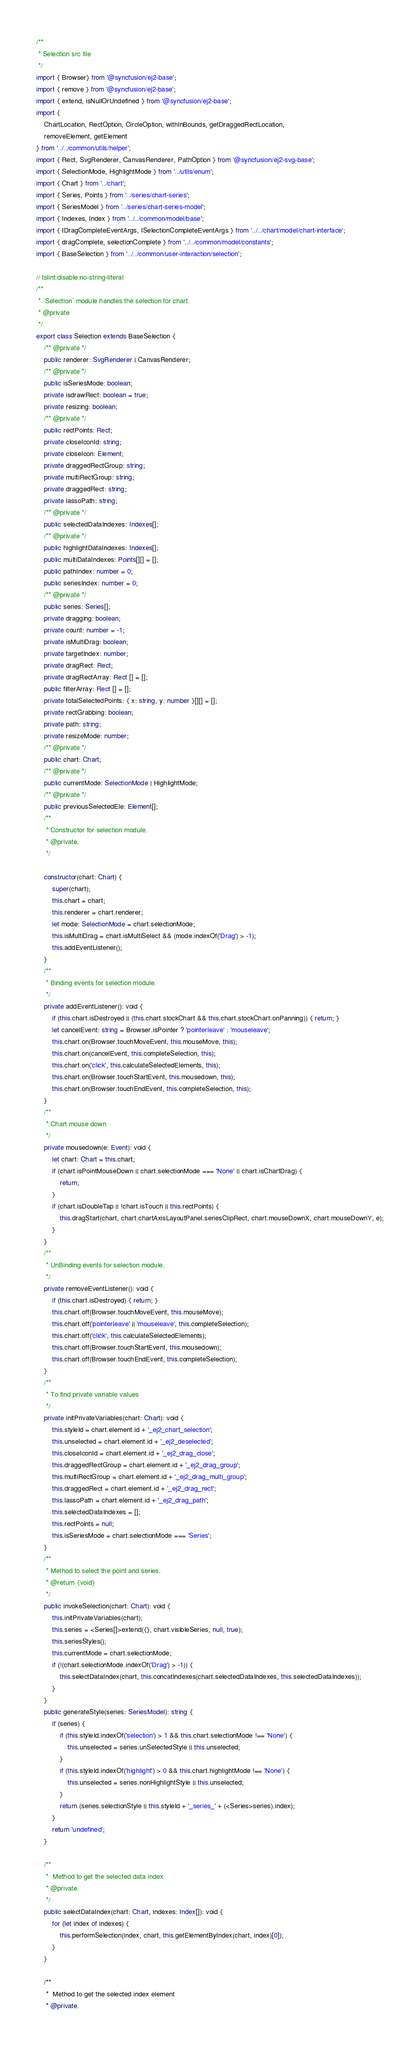Convert code to text. <code><loc_0><loc_0><loc_500><loc_500><_TypeScript_>/**
 * Selection src file
 */
import { Browser} from '@syncfusion/ej2-base';
import { remove } from '@syncfusion/ej2-base';
import { extend, isNullOrUndefined } from '@syncfusion/ej2-base';
import {
    ChartLocation, RectOption, CircleOption, withInBounds, getDraggedRectLocation,
    removeElement, getElement
} from '../../common/utils/helper';
import { Rect, SvgRenderer, CanvasRenderer, PathOption } from '@syncfusion/ej2-svg-base';
import { SelectionMode, HighlightMode } from '../utils/enum';
import { Chart } from '../chart';
import { Series, Points } from '../series/chart-series';
import { SeriesModel } from '../series/chart-series-model';
import { Indexes, Index } from '../../common/model/base';
import { IDragCompleteEventArgs, ISelectionCompleteEventArgs } from '../../chart/model/chart-interface';
import { dragComplete, selectionComplete } from '../../common/model/constants';
import { BaseSelection } from '../../common/user-interaction/selection';

// tslint:disable:no-string-literal
/**
 * `Selection` module handles the selection for chart.
 * @private
 */
export class Selection extends BaseSelection {
    /** @private */
    public renderer: SvgRenderer | CanvasRenderer;
    /** @private */
    public isSeriesMode: boolean;
    private isdrawRect: boolean = true;
    private resizing: boolean;
    /** @private */
    public rectPoints: Rect;
    private closeIconId: string;
    private closeIcon: Element;
    private draggedRectGroup: string;
    private multiRectGroup: string;
    private draggedRect: string;
    private lassoPath: string;
    /** @private */
    public selectedDataIndexes: Indexes[];
    /** @private */
    public highlightDataIndexes: Indexes[];
    public multiDataIndexes: Points[][] = [];
    public pathIndex: number = 0;
    public seriesIndex: number = 0;
    /** @private */
    public series: Series[];
    private dragging: boolean;
    private count: number = -1;
    private isMultiDrag: boolean;
    private targetIndex: number;
    private dragRect: Rect;
    private dragRectArray: Rect [] = [];
    public filterArray: Rect [] = [];
    private totalSelectedPoints: { x: string, y: number }[][] = [];
    private rectGrabbing: boolean;
    private path: string;
    private resizeMode: number;
    /** @private */
    public chart: Chart;
    /** @private */
    public currentMode: SelectionMode | HighlightMode;
    /** @private */
    public previousSelectedEle: Element[];
    /**
     * Constructor for selection module.
     * @private.
     */

    constructor(chart: Chart) {
        super(chart);
        this.chart = chart;
        this.renderer = chart.renderer;
        let mode: SelectionMode = chart.selectionMode;
        this.isMultiDrag = chart.isMultiSelect && (mode.indexOf('Drag') > -1);
        this.addEventListener();
    }
    /**
     * Binding events for selection module.
     */
    private addEventListener(): void {
        if (this.chart.isDestroyed || (this.chart.stockChart && this.chart.stockChart.onPanning)) { return; }
        let cancelEvent: string = Browser.isPointer ? 'pointerleave' : 'mouseleave';
        this.chart.on(Browser.touchMoveEvent, this.mouseMove, this);
        this.chart.on(cancelEvent, this.completeSelection, this);
        this.chart.on('click', this.calculateSelectedElements, this);
        this.chart.on(Browser.touchStartEvent, this.mousedown, this);
        this.chart.on(Browser.touchEndEvent, this.completeSelection, this);
    }
    /**
     * Chart mouse down
     */
    private mousedown(e: Event): void {
        let chart: Chart = this.chart;
        if (chart.isPointMouseDown || chart.selectionMode === 'None' || chart.isChartDrag) {
            return;
        }
        if (chart.isDoubleTap || !chart.isTouch || this.rectPoints) {
            this.dragStart(chart, chart.chartAxisLayoutPanel.seriesClipRect, chart.mouseDownX, chart.mouseDownY, e);
        }
    }
    /**
     * UnBinding events for selection module.
     */
    private removeEventListener(): void {
        if (this.chart.isDestroyed) { return; }
        this.chart.off(Browser.touchMoveEvent, this.mouseMove);
        this.chart.off('pointerleave' || 'mouseleave', this.completeSelection);
        this.chart.off('click', this.calculateSelectedElements);
        this.chart.off(Browser.touchStartEvent, this.mousedown);
        this.chart.off(Browser.touchEndEvent, this.completeSelection);
    }
    /**
     * To find private variable values
     */
    private initPrivateVariables(chart: Chart): void {
        this.styleId = chart.element.id + '_ej2_chart_selection';
        this.unselected = chart.element.id + '_ej2_deselected';
        this.closeIconId = chart.element.id + '_ej2_drag_close';
        this.draggedRectGroup = chart.element.id + '_ej2_drag_group';
        this.multiRectGroup = chart.element.id + '_ej2_drag_multi_group';
        this.draggedRect = chart.element.id + '_ej2_drag_rect';
        this.lassoPath = chart.element.id + '_ej2_drag_path';
        this.selectedDataIndexes = [];
        this.rectPoints = null;
        this.isSeriesMode = chart.selectionMode === 'Series';
    }
    /**
     * Method to select the point and series.
     * @return {void}
     */
    public invokeSelection(chart: Chart): void {
        this.initPrivateVariables(chart);
        this.series = <Series[]>extend({}, chart.visibleSeries, null, true);
        this.seriesStyles();
        this.currentMode = chart.selectionMode;
        if (!(chart.selectionMode.indexOf('Drag') > -1)) {
            this.selectDataIndex(chart, this.concatIndexes(chart.selectedDataIndexes, this.selectedDataIndexes));
        }
    }
    public generateStyle(series: SeriesModel): string {
        if (series) {
            if (this.styleId.indexOf('selection') > 1 && this.chart.selectionMode !== 'None') {
                this.unselected = series.unSelectedStyle || this.unselected;
            }
            if (this.styleId.indexOf('highlight') > 0 && this.chart.highlightMode !== 'None') {
                this.unselected = series.nonHighlightStyle || this.unselected;
            }
            return (series.selectionStyle || this.styleId + '_series_' + (<Series>series).index);
        }
        return 'undefined';
    }

    /**
     *  Method to get the selected data index
     * @private.
     */
    public selectDataIndex(chart: Chart, indexes: Index[]): void {
        for (let index of indexes) {
            this.performSelection(index, chart, this.getElementByIndex(chart, index)[0]);
        }
    }

    /**
     *  Method to get the selected index element
     * @private.</code> 